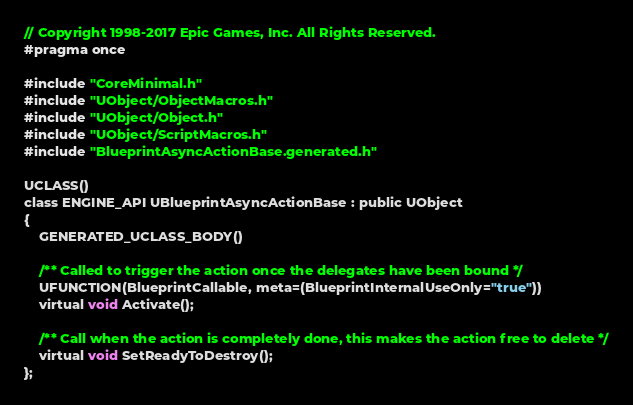Convert code to text. <code><loc_0><loc_0><loc_500><loc_500><_C_>// Copyright 1998-2017 Epic Games, Inc. All Rights Reserved.
#pragma once

#include "CoreMinimal.h"
#include "UObject/ObjectMacros.h"
#include "UObject/Object.h"
#include "UObject/ScriptMacros.h"
#include "BlueprintAsyncActionBase.generated.h"

UCLASS()
class ENGINE_API UBlueprintAsyncActionBase : public UObject
{
	GENERATED_UCLASS_BODY()

	/** Called to trigger the action once the delegates have been bound */
	UFUNCTION(BlueprintCallable, meta=(BlueprintInternalUseOnly="true"))
	virtual void Activate();

	/** Call when the action is completely done, this makes the action free to delete */
	virtual void SetReadyToDestroy();
};
</code> 